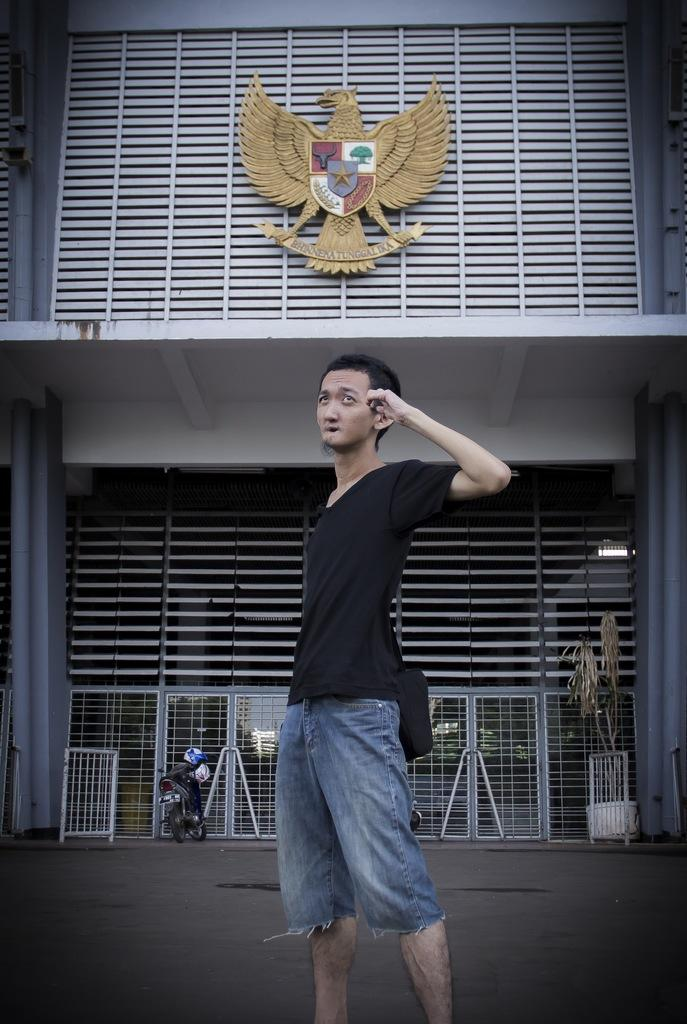Who is the main subject in the picture? There is a person in the center of the picture. What is the person wearing? The person is wearing a black t-shirt. Where is the person standing? The person is standing on the road. What can be seen in the background of the image? There are barricades, a motorbike, and a building in the background of the image. What type of guitar is the person playing in the image? There is no guitar present in the image; the person is not playing any musical instrument. Can you tell me where the nearest store is located in the image? There is no store mentioned or visible in the image. 